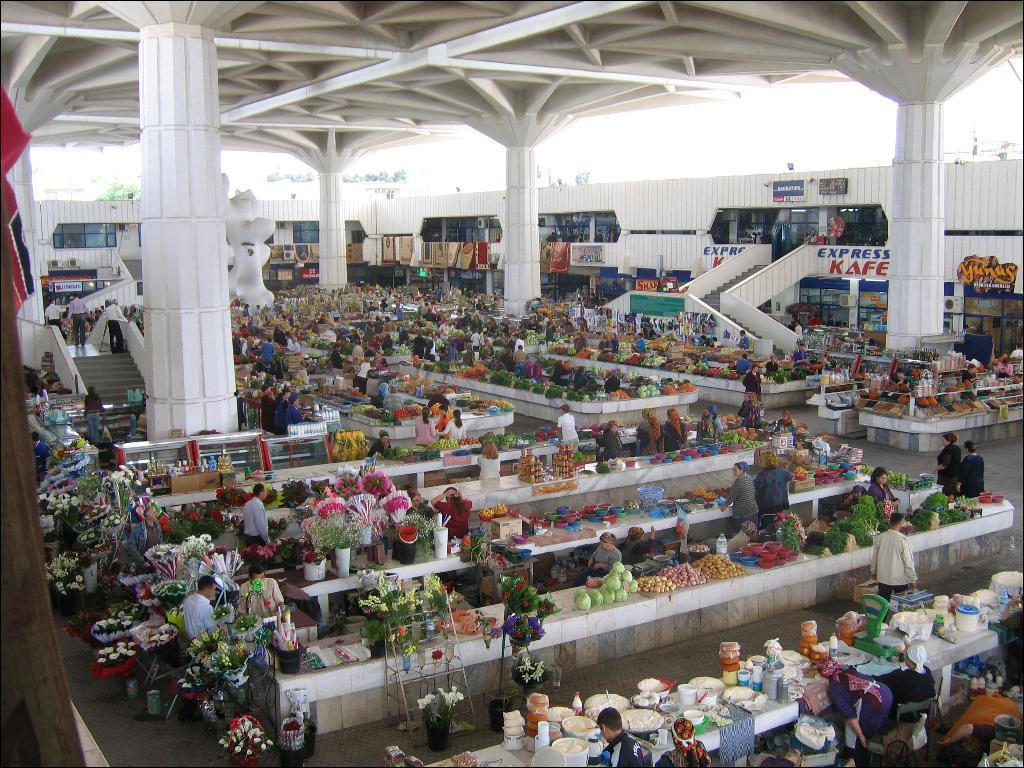<image>
Describe the image concisely. A large room with many tables of bright flowers has an express kafe in the back. 